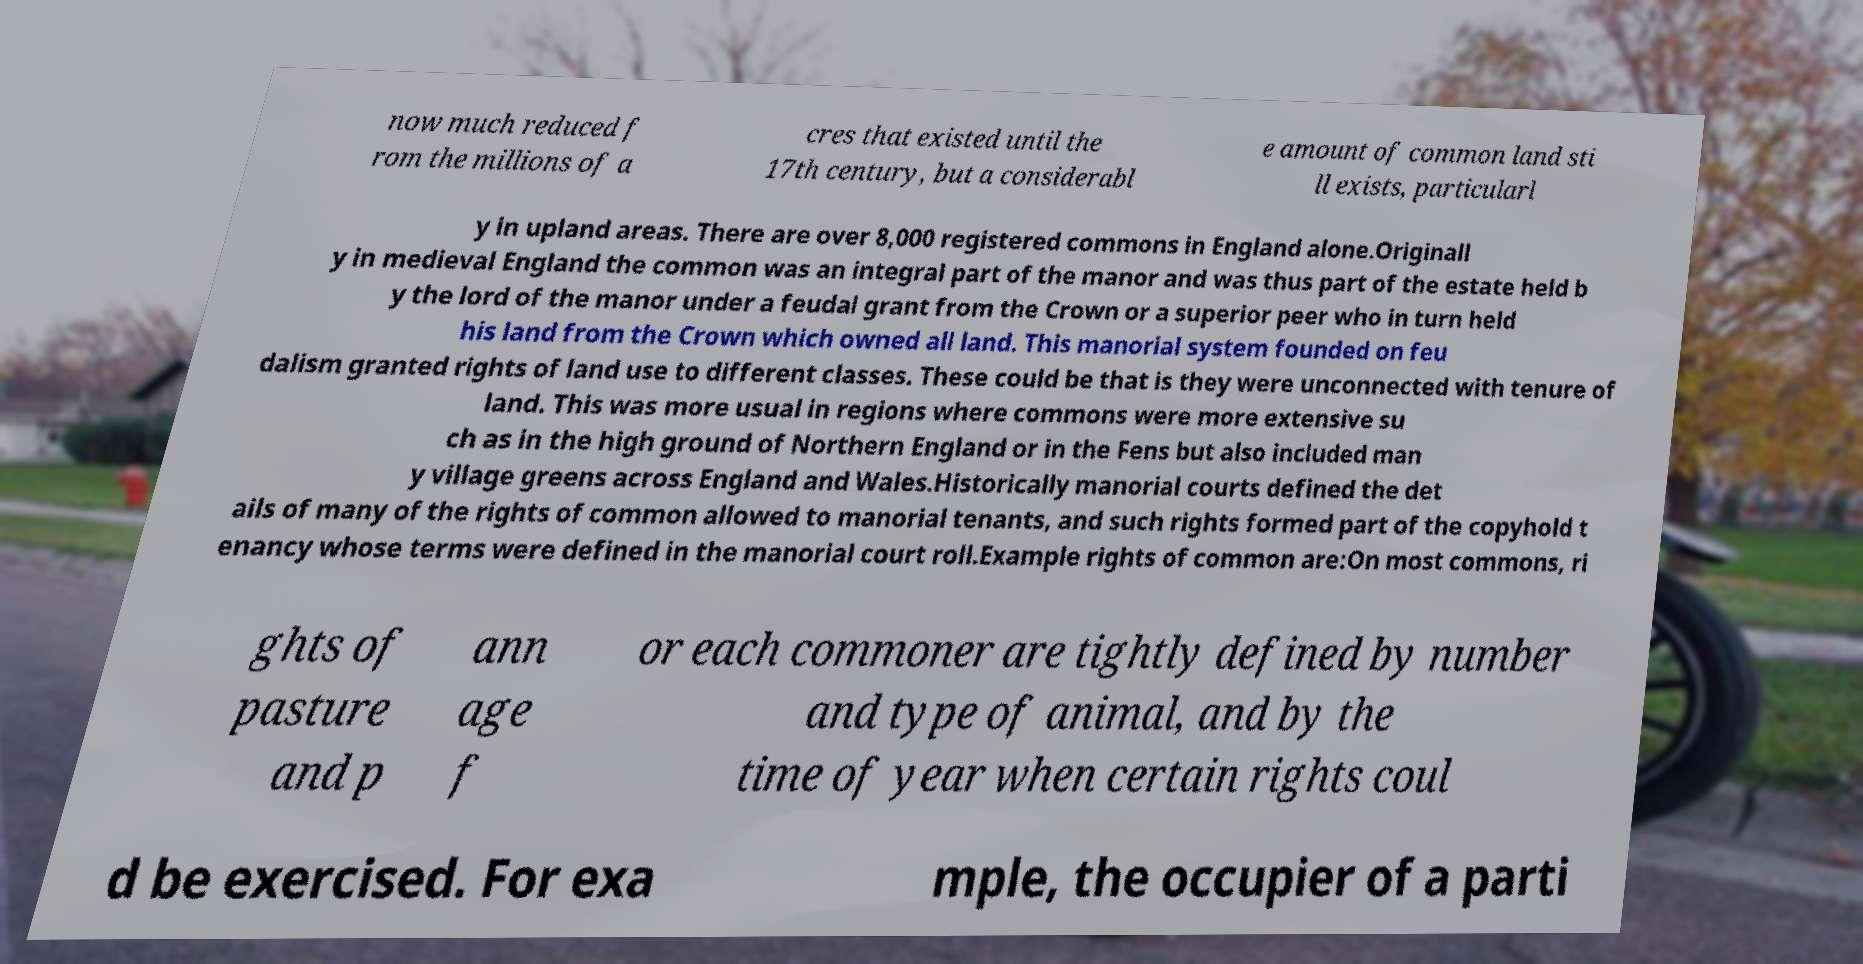Could you assist in decoding the text presented in this image and type it out clearly? now much reduced f rom the millions of a cres that existed until the 17th century, but a considerabl e amount of common land sti ll exists, particularl y in upland areas. There are over 8,000 registered commons in England alone.Originall y in medieval England the common was an integral part of the manor and was thus part of the estate held b y the lord of the manor under a feudal grant from the Crown or a superior peer who in turn held his land from the Crown which owned all land. This manorial system founded on feu dalism granted rights of land use to different classes. These could be that is they were unconnected with tenure of land. This was more usual in regions where commons were more extensive su ch as in the high ground of Northern England or in the Fens but also included man y village greens across England and Wales.Historically manorial courts defined the det ails of many of the rights of common allowed to manorial tenants, and such rights formed part of the copyhold t enancy whose terms were defined in the manorial court roll.Example rights of common are:On most commons, ri ghts of pasture and p ann age f or each commoner are tightly defined by number and type of animal, and by the time of year when certain rights coul d be exercised. For exa mple, the occupier of a parti 